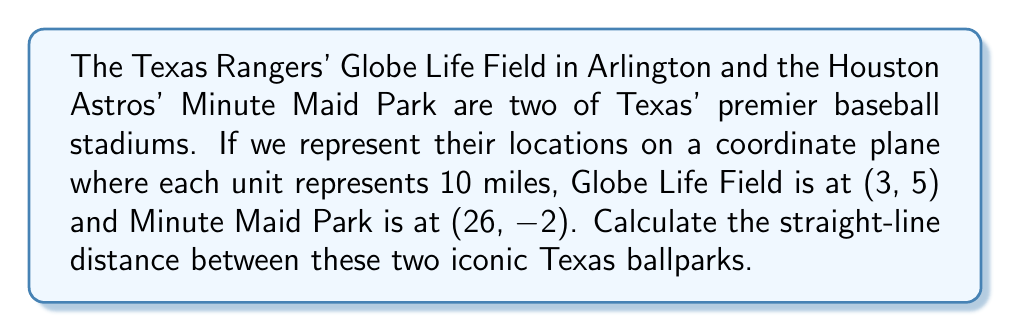What is the answer to this math problem? To find the distance between two points on a coordinate plane, we can use the distance formula, which is derived from the Pythagorean theorem:

$$d = \sqrt{(x_2 - x_1)^2 + (y_2 - y_1)^2}$$

Where $(x_1, y_1)$ represents the coordinates of the first point and $(x_2, y_2)$ represents the coordinates of the second point.

Let's assign our points:
Globe Life Field: $(x_1, y_1) = (3, 5)$
Minute Maid Park: $(x_2, y_2) = (26, -2)$

Now, let's plug these into our formula:

$$d = \sqrt{(26 - 3)^2 + (-2 - 5)^2}$$

Simplify inside the parentheses:
$$d = \sqrt{(23)^2 + (-7)^2}$$

Calculate the squares:
$$d = \sqrt{529 + 49}$$

Add under the square root:
$$d = \sqrt{578}$$

Simplify:
$$d \approx 24.04$$

Since each unit represents 10 miles, we multiply our result by 10:

$$24.04 \times 10 = 240.4$$

Therefore, the straight-line distance between Globe Life Field and Minute Maid Park is approximately 240.4 miles.
Answer: 240.4 miles 